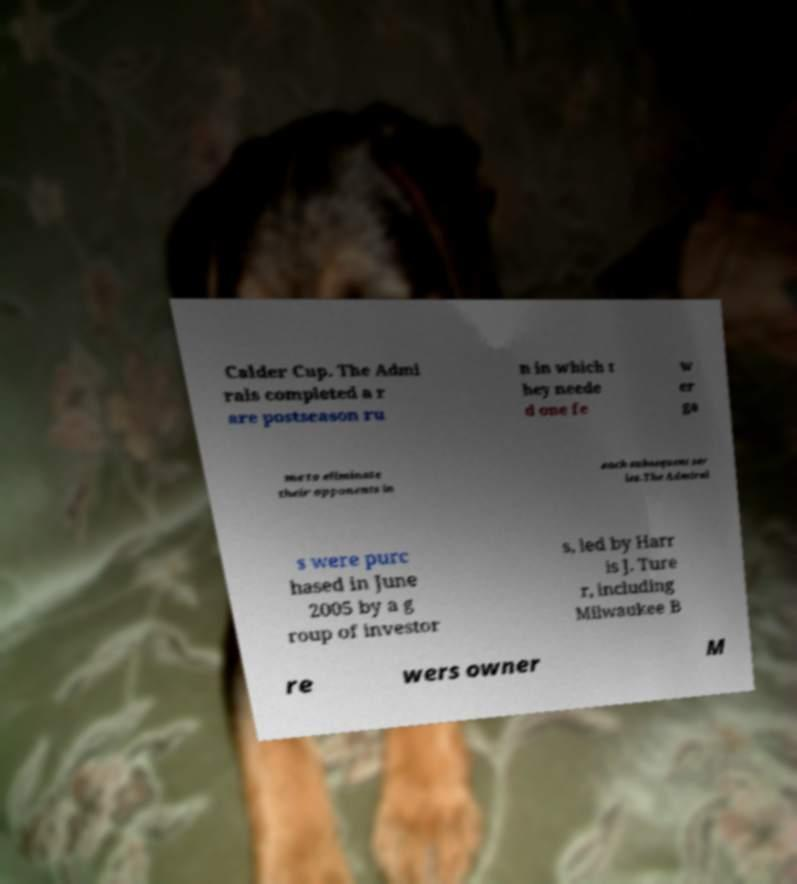Can you accurately transcribe the text from the provided image for me? Calder Cup. The Admi rals completed a r are postseason ru n in which t hey neede d one fe w er ga me to eliminate their opponents in each subsequent ser ies.The Admiral s were purc hased in June 2005 by a g roup of investor s, led by Harr is J. Ture r, including Milwaukee B re wers owner M 